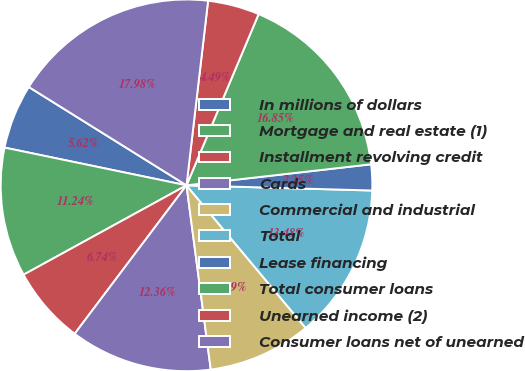<chart> <loc_0><loc_0><loc_500><loc_500><pie_chart><fcel>In millions of dollars<fcel>Mortgage and real estate (1)<fcel>Installment revolving credit<fcel>Cards<fcel>Commercial and industrial<fcel>Total<fcel>Lease financing<fcel>Total consumer loans<fcel>Unearned income (2)<fcel>Consumer loans net of unearned<nl><fcel>5.62%<fcel>11.24%<fcel>6.74%<fcel>12.36%<fcel>8.99%<fcel>13.48%<fcel>2.25%<fcel>16.85%<fcel>4.49%<fcel>17.98%<nl></chart> 